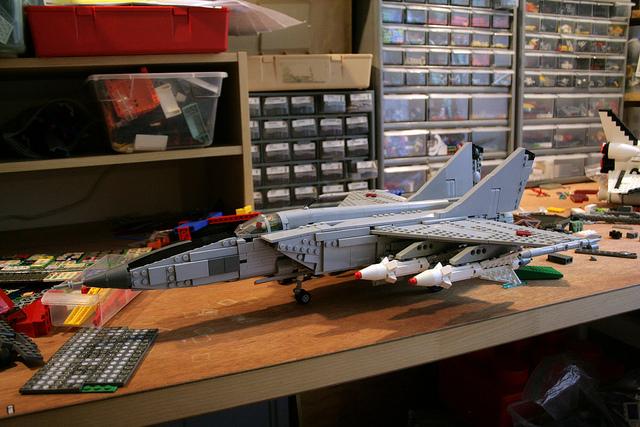Does it look like this plane is completed?
Quick response, please. Yes. How many people will ride in this plane?
Answer briefly. 0. Was this plane built from a kit?
Write a very short answer. Yes. 